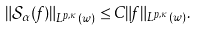<formula> <loc_0><loc_0><loc_500><loc_500>\left \| \mathcal { S } _ { \alpha } ( f ) \right \| _ { L ^ { p , \kappa } ( w ) } \leq C \| f \| _ { L ^ { p , \kappa } ( w ) } .</formula> 